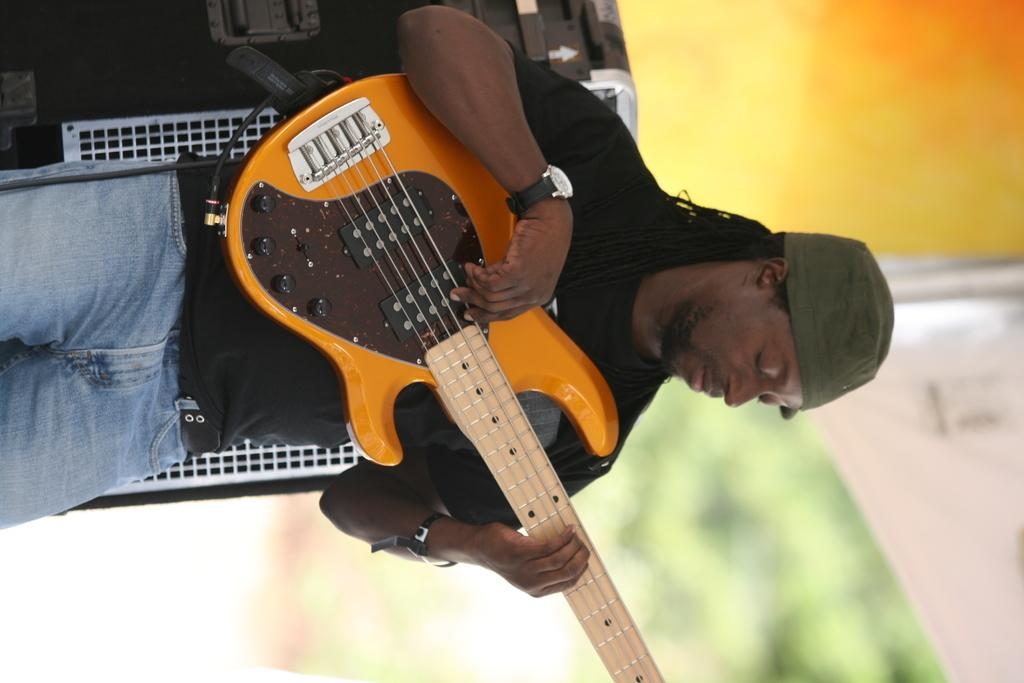What is the main subject of the image? There is a person in the image. What is the person doing in the image? The person is standing in the image. What object is the person holding in the image? The person is holding a guitar in his hand. What type of noise can be heard coming from the donkey in the image? There is no donkey present in the image, so it is not possible to determine what, if any, noise might be heard. 